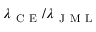Convert formula to latex. <formula><loc_0><loc_0><loc_500><loc_500>\lambda _ { C E } / \lambda _ { J M L }</formula> 